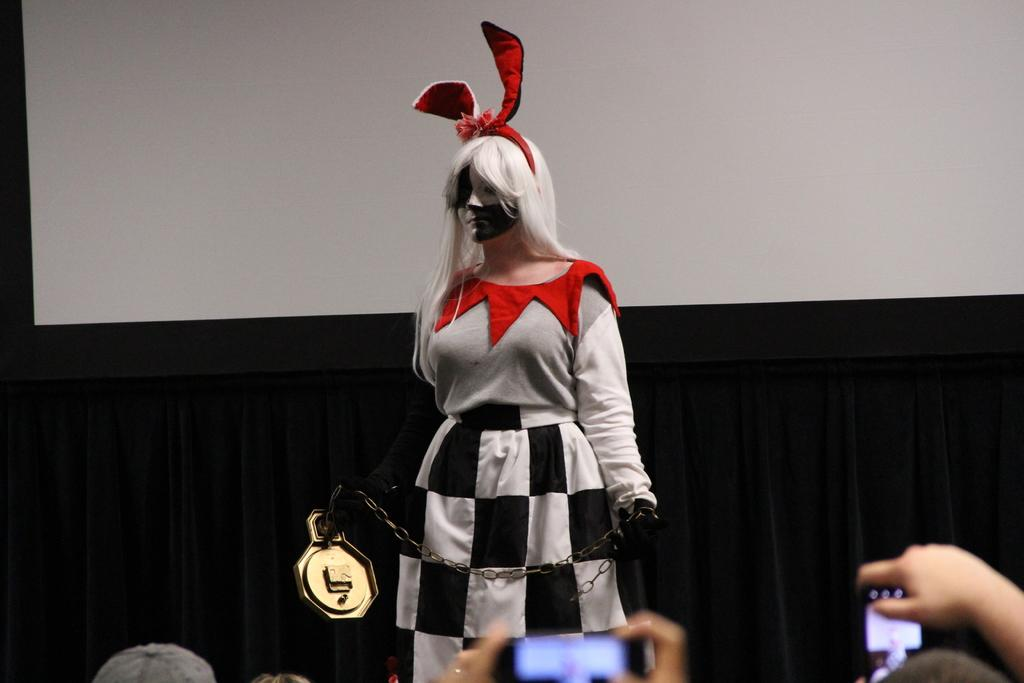What is the person in the image wearing? The person is wearing a costume in the image. What is the person holding in the image? The person is holding a chain with an object in the image. Whose hands are visible at the bottom of the image? There are people's hands visible at the bottom of the image. What can be seen on the screen in the image? Unfortunately, the facts provided do not give any information about what is on the screen. What is in the background of the image? There is a curtain in the background of the image. What type of brass instrument is being played in the image? There is no brass instrument present in the image. What is the topic of the meeting taking place in the image? There is no meeting taking place in the image. 